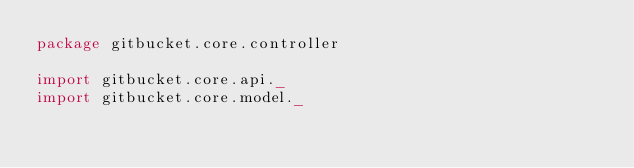Convert code to text. <code><loc_0><loc_0><loc_500><loc_500><_Scala_>package gitbucket.core.controller

import gitbucket.core.api._
import gitbucket.core.model._</code> 